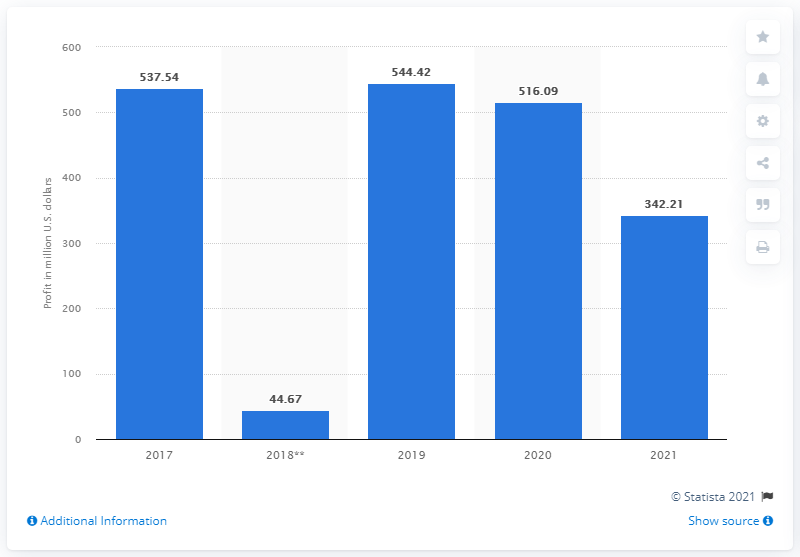Give some essential details in this illustration. In 2021, the outdoor segment of VF Corporation reported a revenue of 342.21 million dollars. 